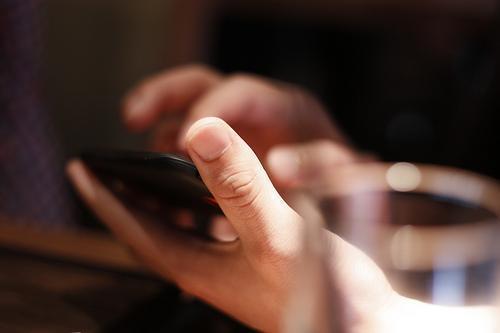How many people are in the photo?
Give a very brief answer. 1. 